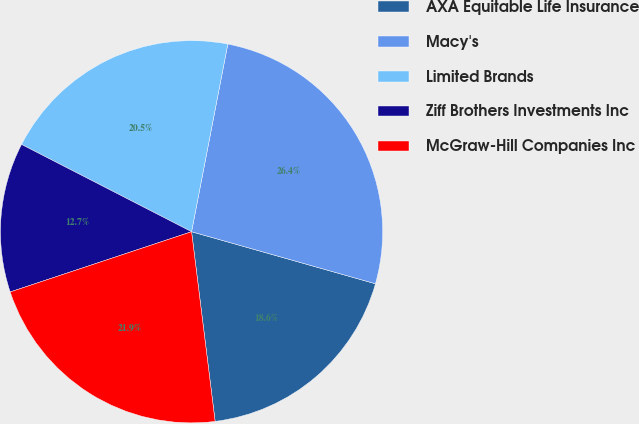<chart> <loc_0><loc_0><loc_500><loc_500><pie_chart><fcel>AXA Equitable Life Insurance<fcel>Macy's<fcel>Limited Brands<fcel>Ziff Brothers Investments Inc<fcel>McGraw-Hill Companies Inc<nl><fcel>18.64%<fcel>26.35%<fcel>20.49%<fcel>12.65%<fcel>21.86%<nl></chart> 